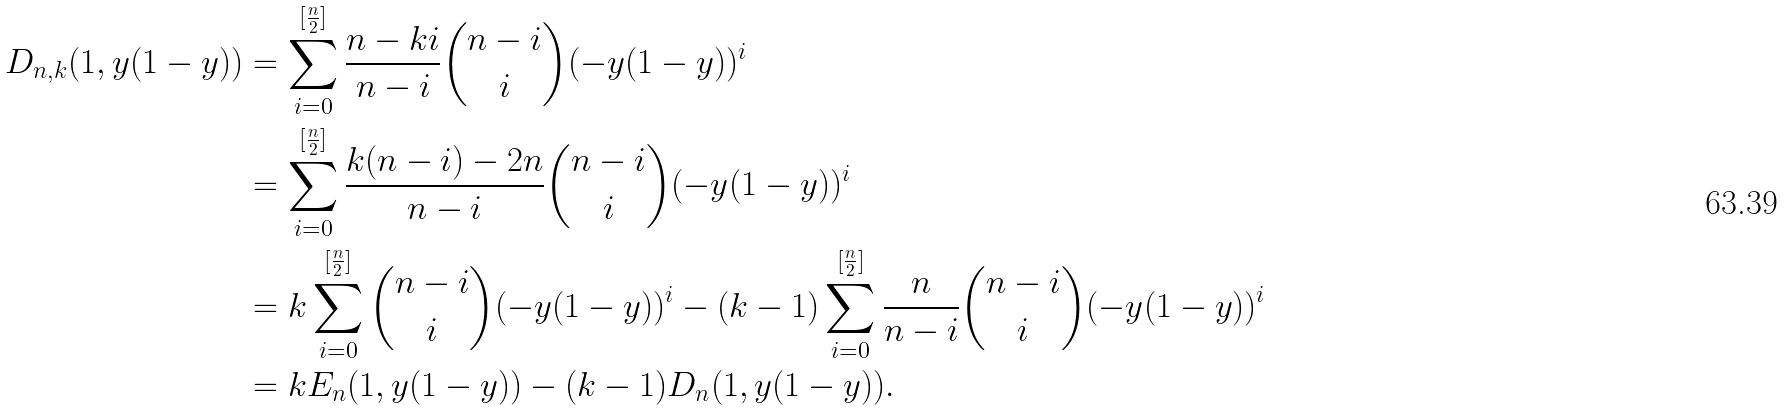Convert formula to latex. <formula><loc_0><loc_0><loc_500><loc_500>D _ { n , k } ( 1 , y ( 1 - y ) ) & = \sum _ { i = 0 } ^ { [ \frac { n } { 2 } ] } \frac { n - k i } { n - i } \binom { n - i } { i } ( - y ( 1 - y ) ) ^ { i } \\ & = \sum _ { i = 0 } ^ { [ \frac { n } { 2 } ] } \frac { k ( n - i ) - 2 n } { n - i } \binom { n - i } { i } ( - y ( 1 - y ) ) ^ { i } \\ & = k \sum _ { i = 0 } ^ { [ \frac { n } { 2 } ] } \binom { n - i } { i } ( - y ( 1 - y ) ) ^ { i } - ( k - 1 ) \sum _ { i = 0 } ^ { [ \frac { n } { 2 } ] } \frac { n } { n - i } \binom { n - i } { i } ( - y ( 1 - y ) ) ^ { i } \\ & = k E _ { n } ( 1 , y ( 1 - y ) ) - ( k - 1 ) D _ { n } ( 1 , y ( 1 - y ) ) .</formula> 